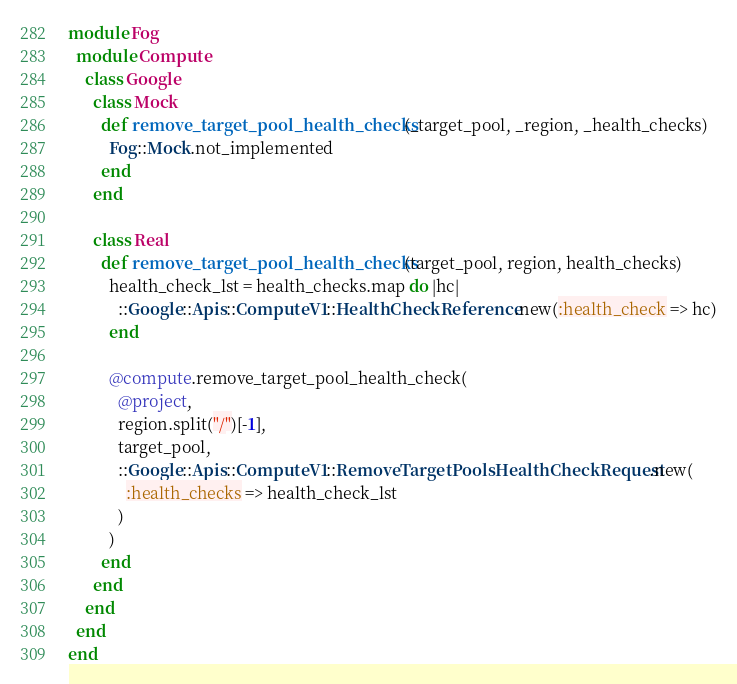Convert code to text. <code><loc_0><loc_0><loc_500><loc_500><_Ruby_>module Fog
  module Compute
    class Google
      class Mock
        def remove_target_pool_health_checks(_target_pool, _region, _health_checks)
          Fog::Mock.not_implemented
        end
      end

      class Real
        def remove_target_pool_health_checks(target_pool, region, health_checks)
          health_check_lst = health_checks.map do |hc|
            ::Google::Apis::ComputeV1::HealthCheckReference.new(:health_check => hc)
          end

          @compute.remove_target_pool_health_check(
            @project,
            region.split("/")[-1],
            target_pool,
            ::Google::Apis::ComputeV1::RemoveTargetPoolsHealthCheckRequest.new(
              :health_checks => health_check_lst
            )
          )
        end
      end
    end
  end
end
</code> 